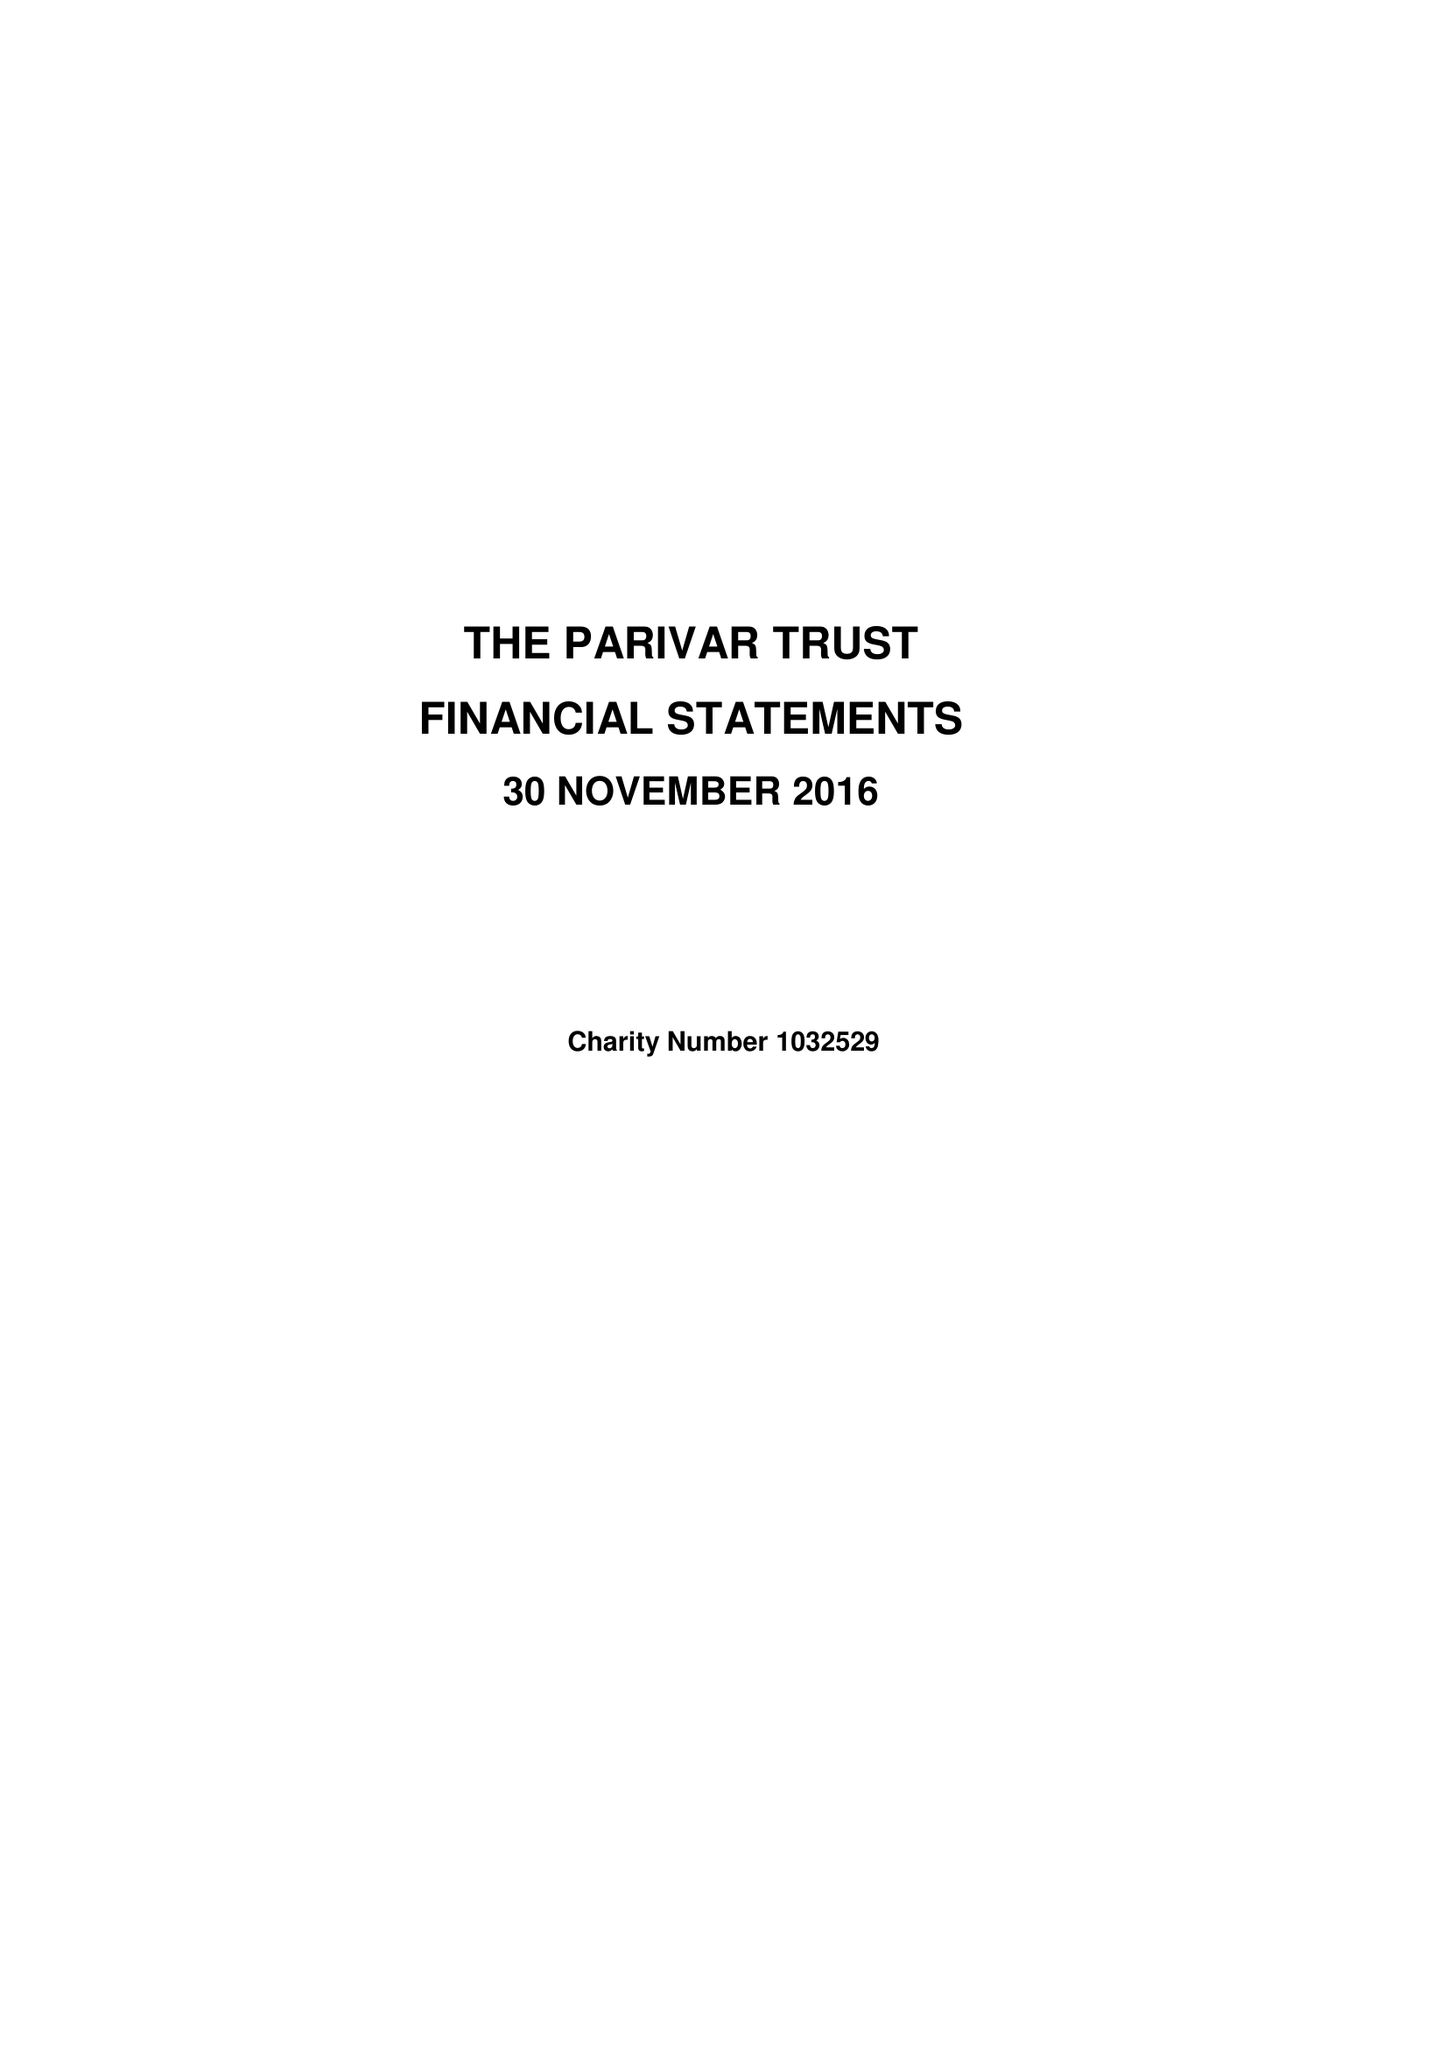What is the value for the income_annually_in_british_pounds?
Answer the question using a single word or phrase. 88789.00 